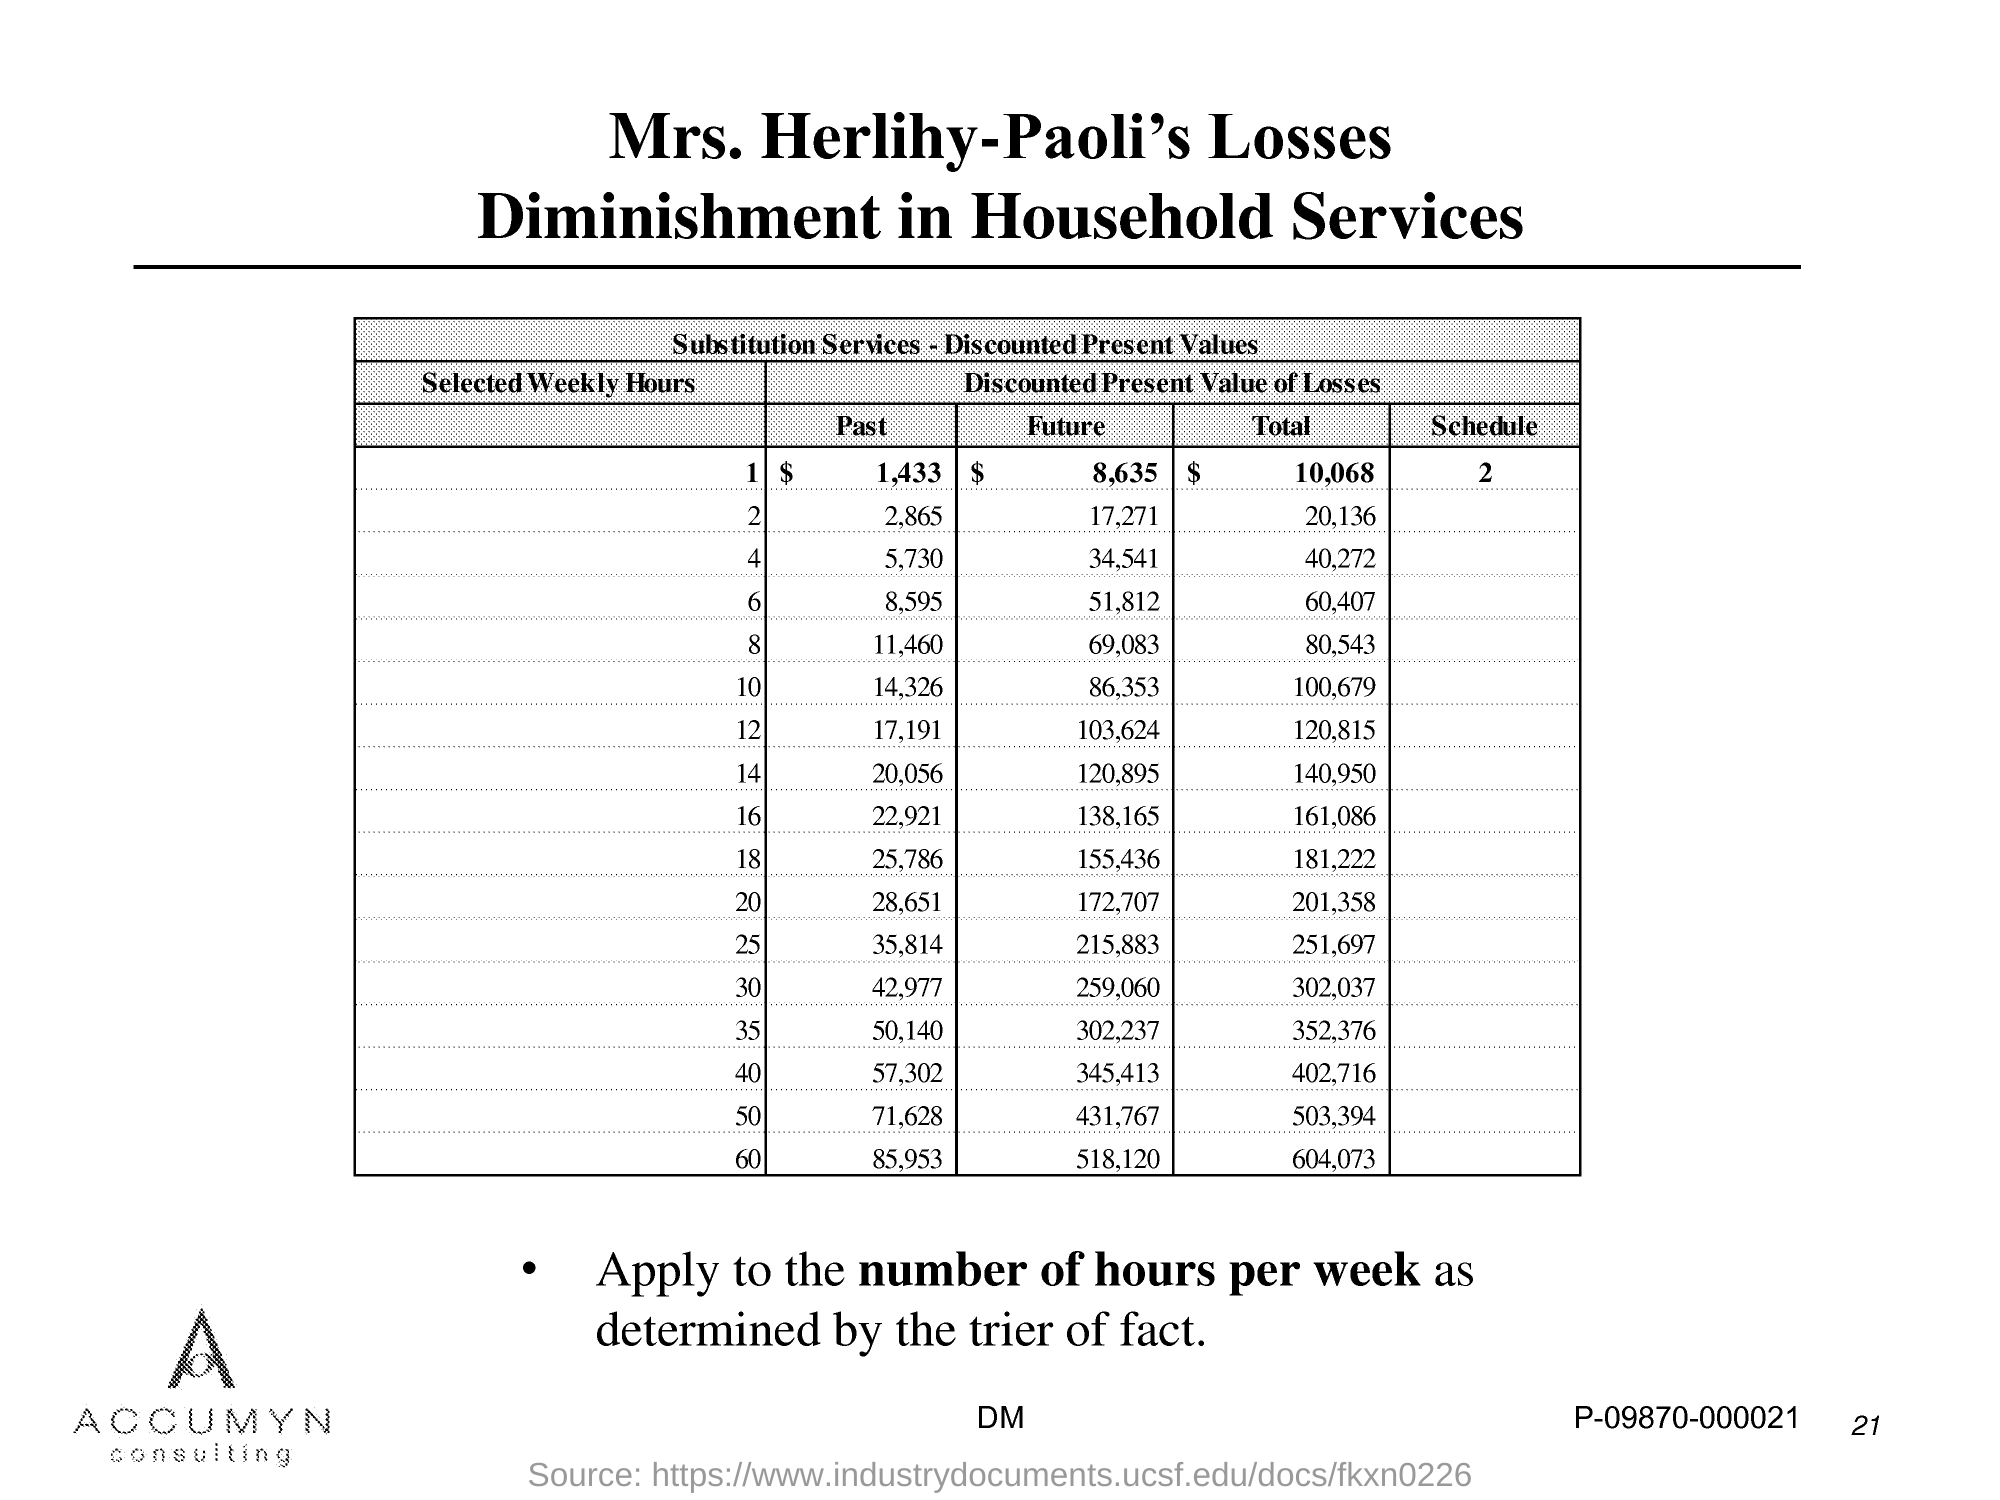Give some essential details in this illustration. The second title in the document is 'Diminishment in Household Services.' The first title in the document is "Mrs. Herlihy-Paoli's Losses. The page number is 21. There are two schedules. For the selected weekly hour of 1, the total amount is 10,068. 